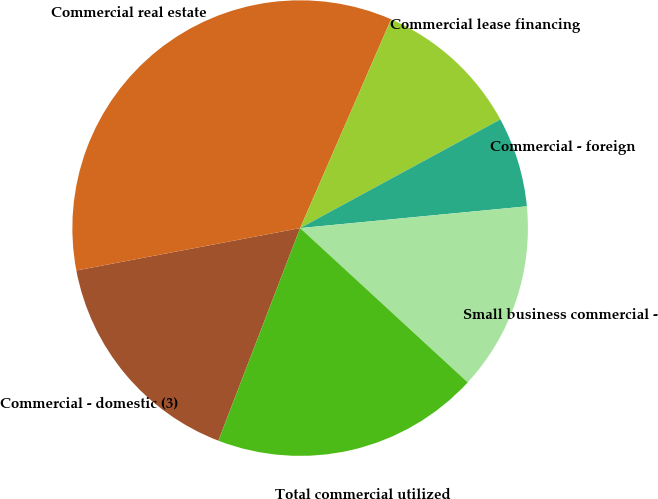Convert chart. <chart><loc_0><loc_0><loc_500><loc_500><pie_chart><fcel>Commercial - domestic (3)<fcel>Commercial real estate<fcel>Commercial lease financing<fcel>Commercial - foreign<fcel>Small business commercial -<fcel>Total commercial utilized<nl><fcel>16.18%<fcel>34.52%<fcel>10.55%<fcel>6.39%<fcel>13.37%<fcel>19.0%<nl></chart> 